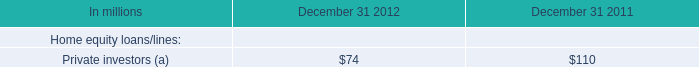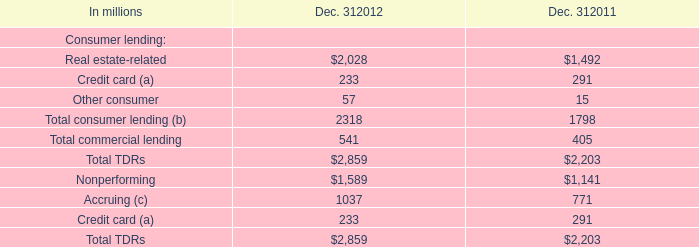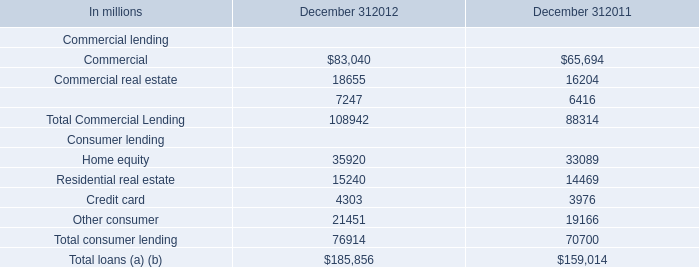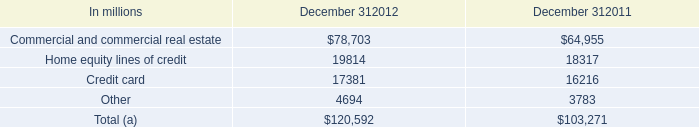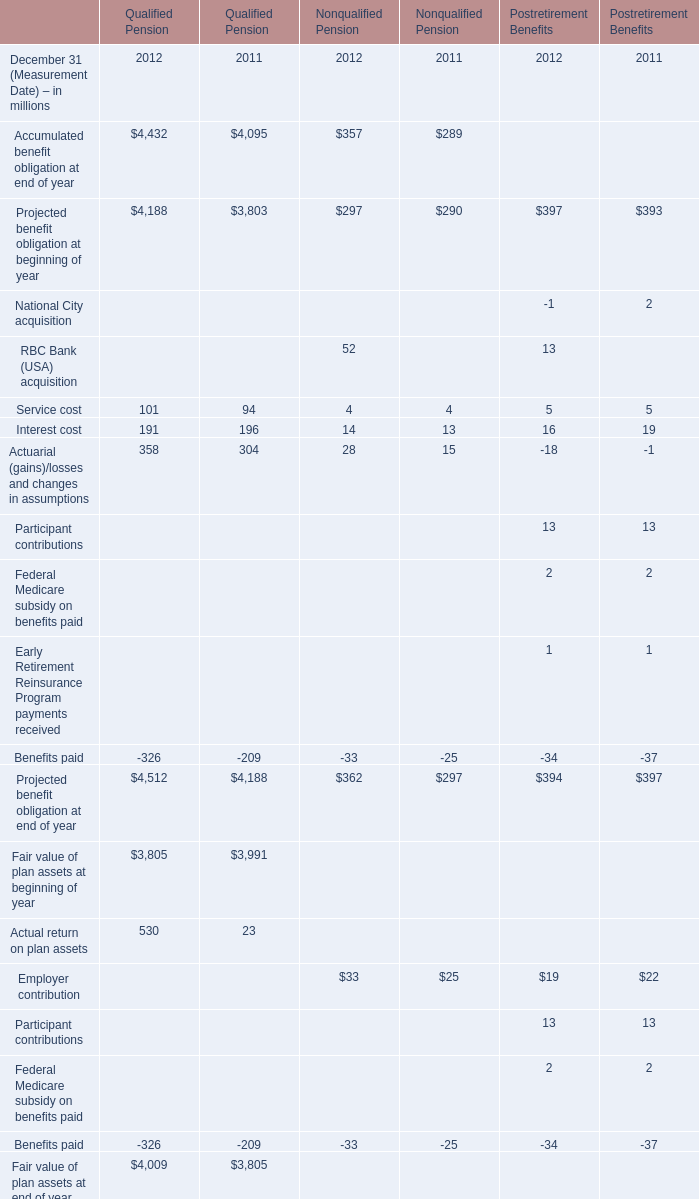how many total private investor repurchase claims were there in 2011 and 2012 combined , in millions? 
Computations: (74 + 110)
Answer: 184.0. 